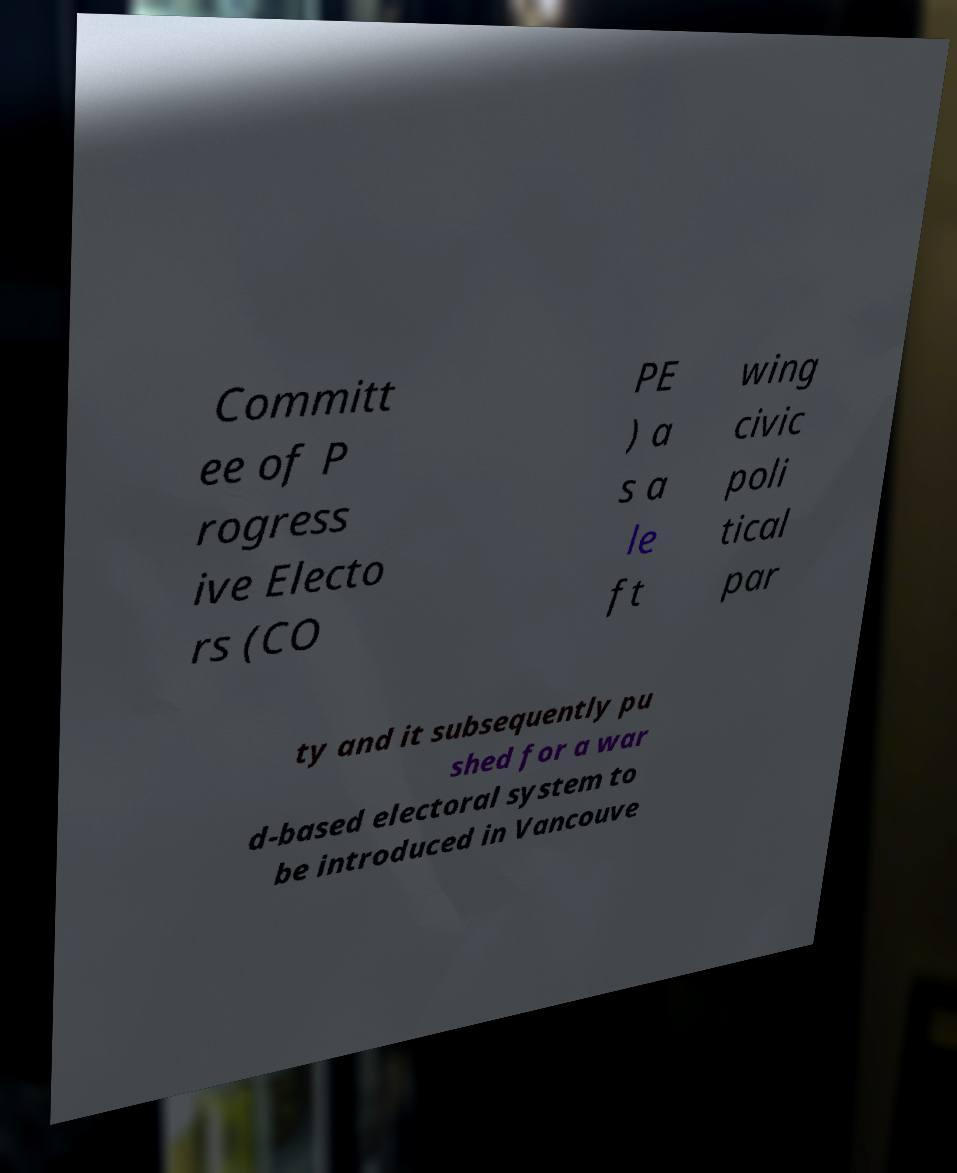I need the written content from this picture converted into text. Can you do that? Committ ee of P rogress ive Electo rs (CO PE ) a s a le ft wing civic poli tical par ty and it subsequently pu shed for a war d-based electoral system to be introduced in Vancouve 